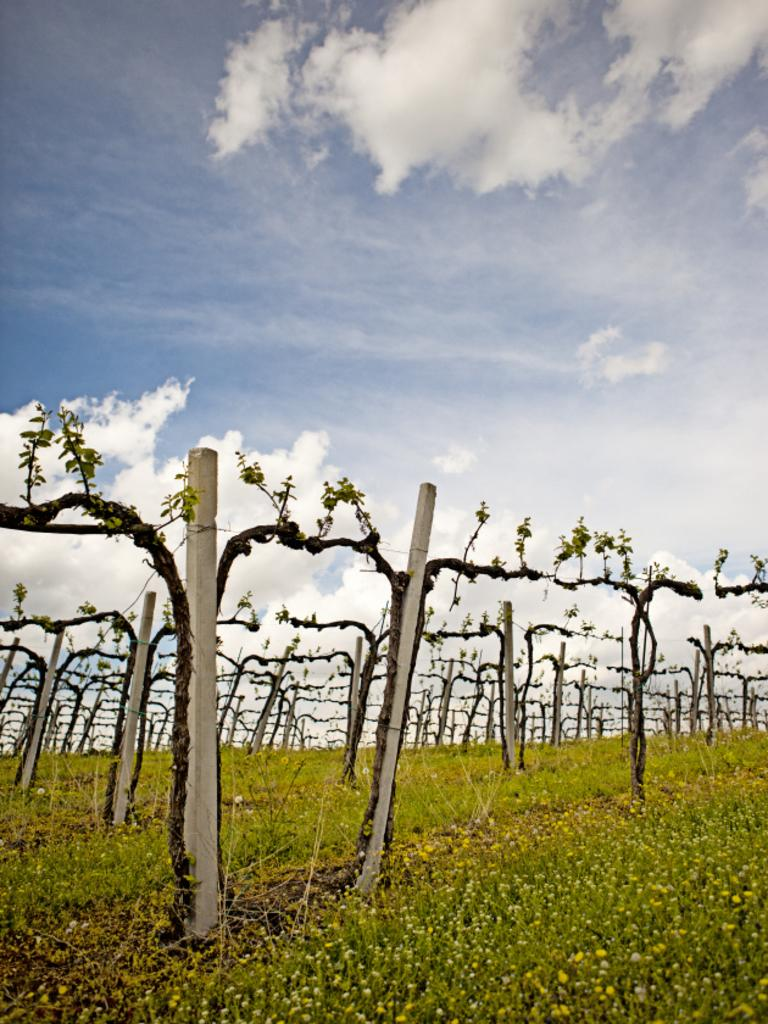What type of living organisms are present in the image? There is a group of plants in the image. What structures can be seen in the image? There are poles in the image. What is visible in the foreground of the image? The foreground of the image includes grass. What is visible in the background of the image? The background of the image includes a cloudy sky. What type of dinner is being served to the beggar in the image? There is no dinner or beggar present in the image; it features a group of plants, poles, grass, and a cloudy sky. 